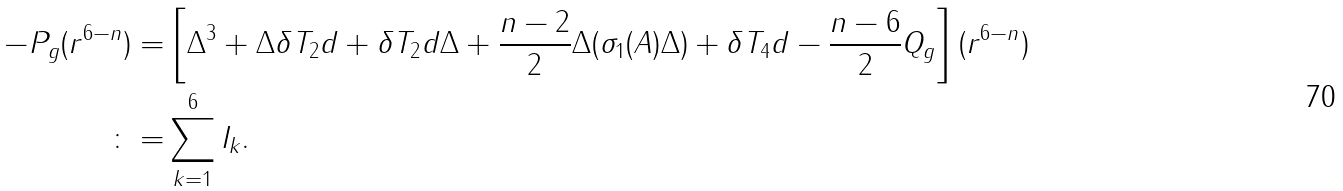<formula> <loc_0><loc_0><loc_500><loc_500>- P _ { g } ( r ^ { 6 - n } ) = & \left [ \Delta ^ { 3 } + \Delta \delta T _ { 2 } d + \delta T _ { 2 } d \Delta + \frac { n - 2 } { 2 } \Delta ( \sigma _ { 1 } ( A ) \Delta ) + \delta T _ { 4 } d - \frac { n - 6 } { 2 } Q _ { g } \right ] ( r ^ { 6 - n } ) \\ \colon = & \sum _ { k = 1 } ^ { 6 } I _ { k } .</formula> 